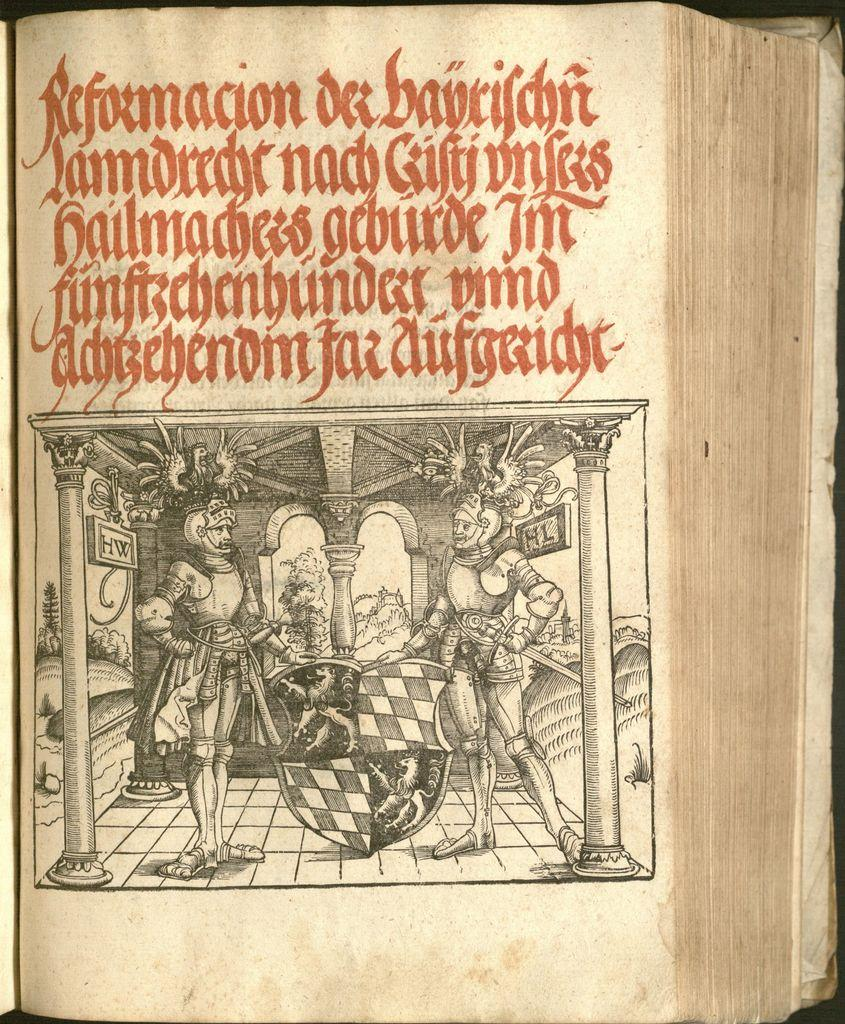Provide a one-sentence caption for the provided image. A book is opened to a page illustrated with men in armor and the first word at the top of the page is Reformacion. 